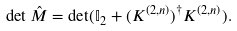<formula> <loc_0><loc_0><loc_500><loc_500>\det \hat { M } = \det ( { \mathbb { I } } _ { 2 } + ( K ^ { ( 2 , n ) } ) ^ { \dagger } K ^ { ( 2 , n ) } ) .</formula> 